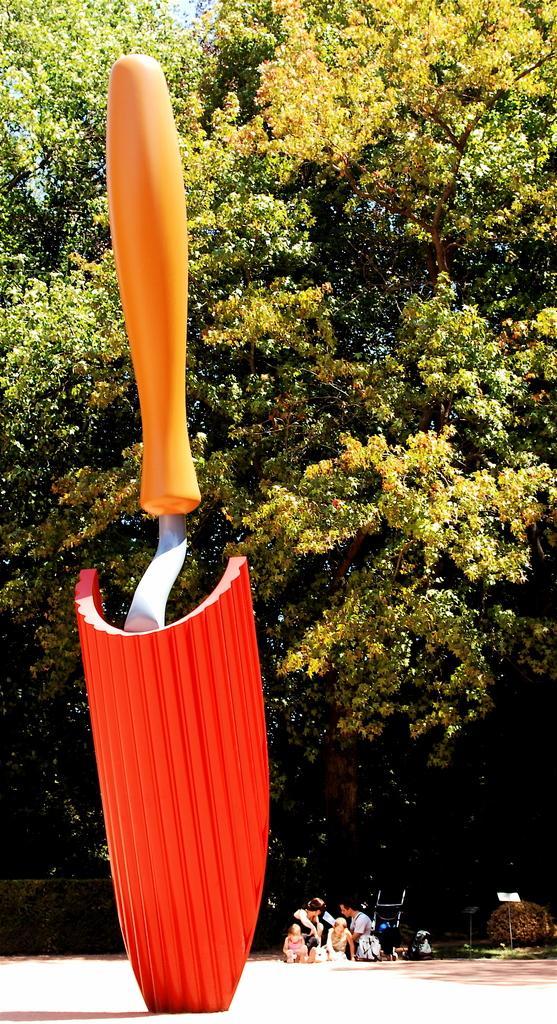In one or two sentences, can you explain what this image depicts? In this image we can see a statue. On the backside we can see some people on the ground, a fence, some plants, a group of trees and the sky. 